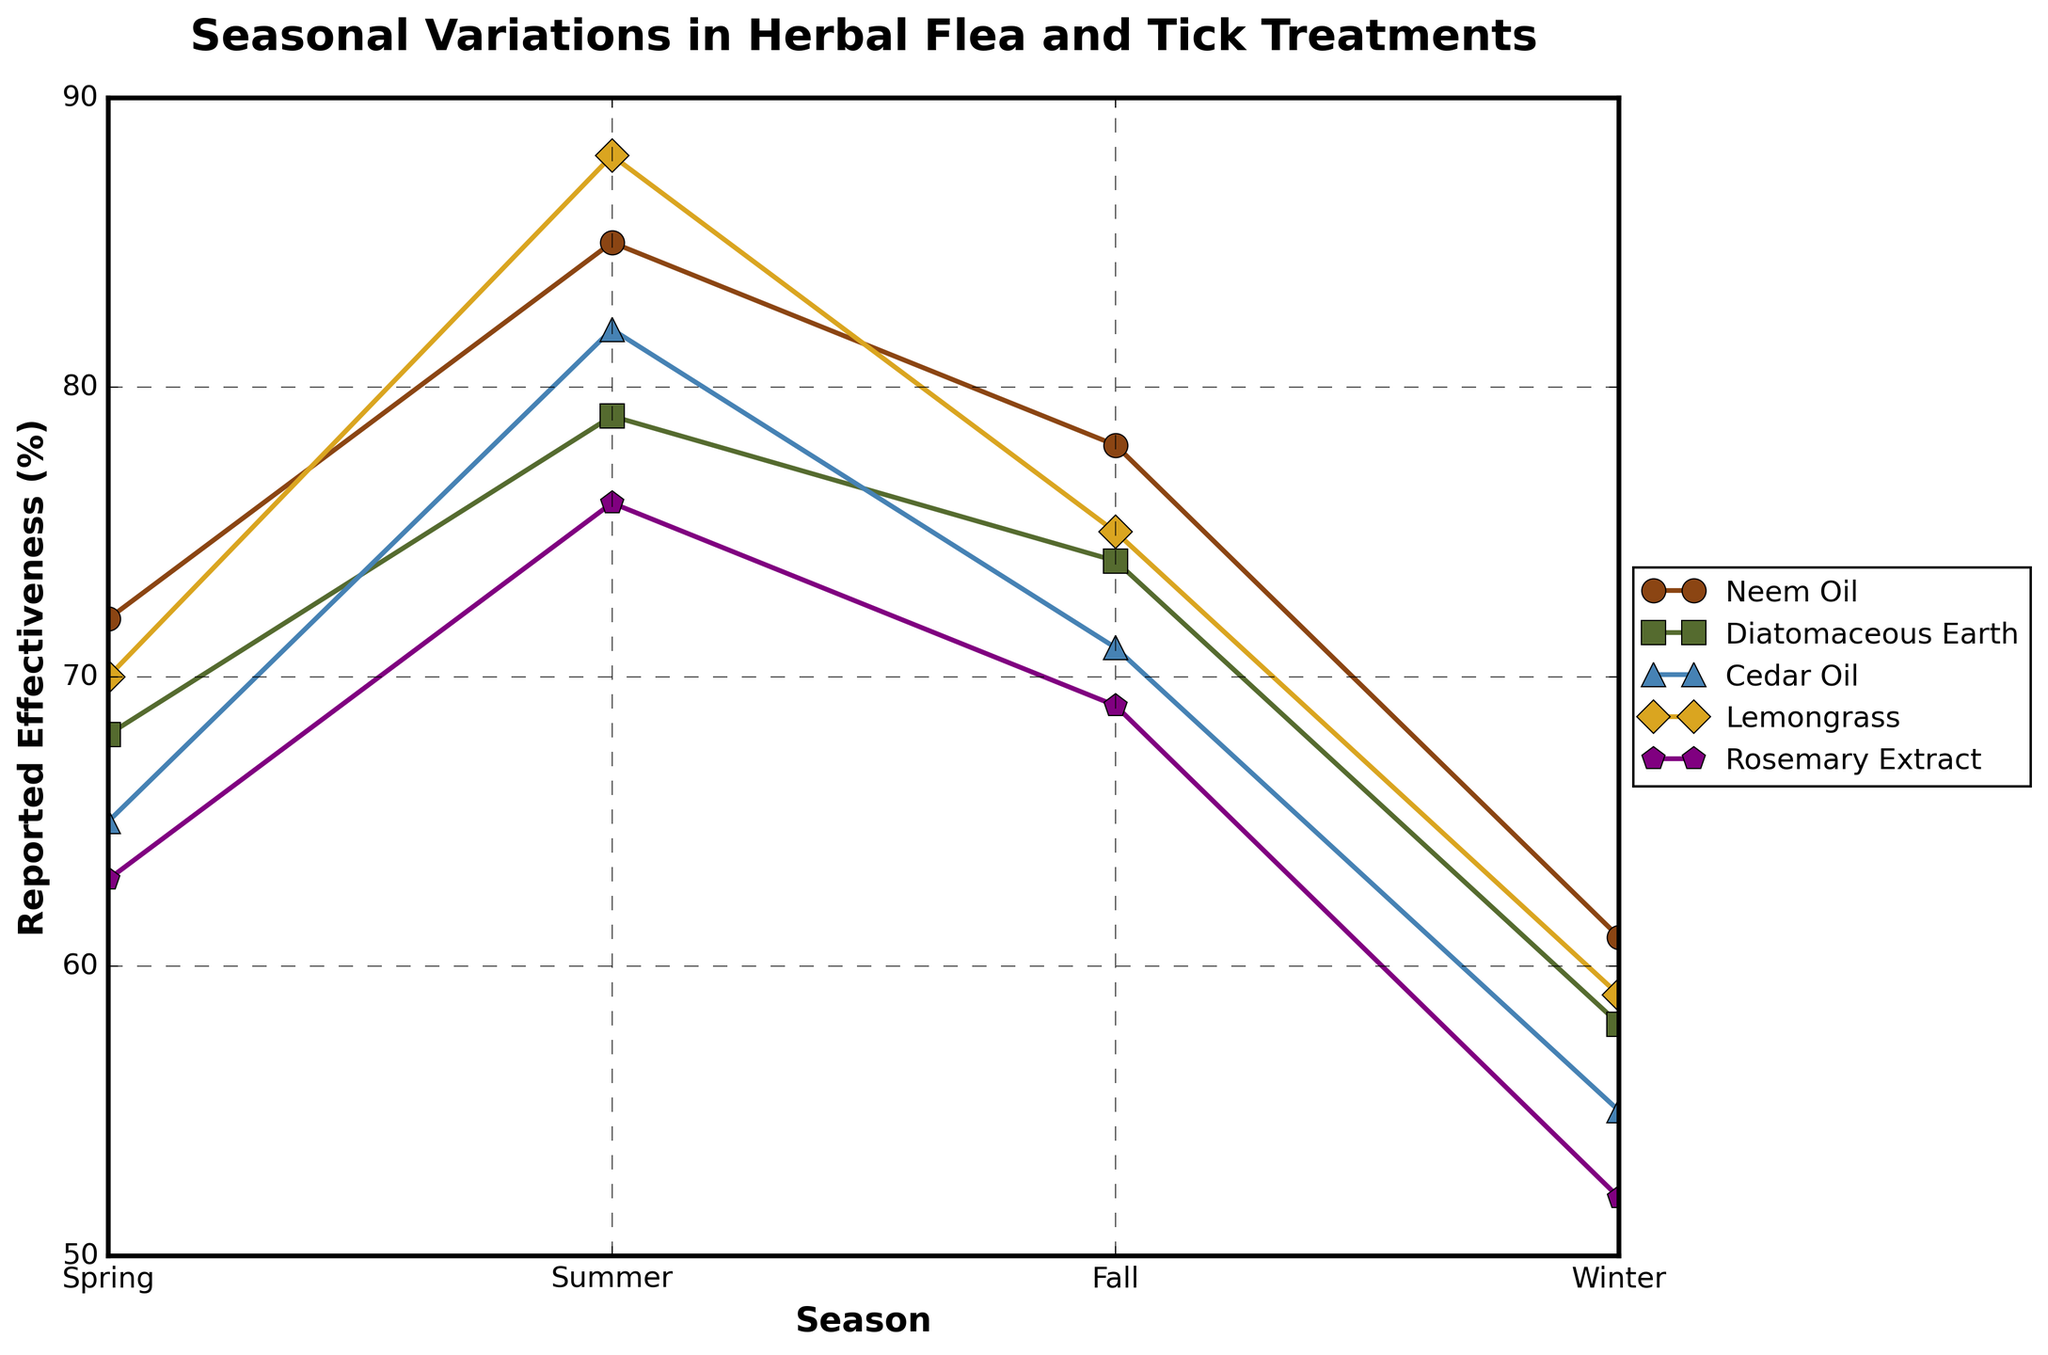What's the overall trend of the effectiveness of Neem Oil across seasons? Neem Oil's effectiveness shows a peak in Summer at 85%, declines in Fall to 78%, and further drops in Winter to 61%. It starts rising again in Spring to 72%. So, the trend is a peak in Summer and a dip in Winter.
Answer: Peak in Summer, Dip in Winter Which treatment maintains the most consistent effectiveness throughout the year? To determine consistency, we need to identify the treatment with the smallest range of effectiveness values over the seasons. Diatomaceous Earth ranges from 58% to 79% (a range of 21%), Cedar Oil ranges from 55% to 82% (a range of 27%), Neem Oil ranges from 61% to 85% (a range of 24%), Lemongrass ranges from 59% to 88% (a range of 29%), and Rosemary Extract ranges from 52% to 76% (a range of 24%). Diatomaceous Earth has the smallest range, indicating the most consistent effectiveness.
Answer: Diatomaceous Earth Which season shows the highest effectiveness for Lemongrass? By looking at the plot, we can see that Lemongrass's highest effectiveness is in Summer at 88%.
Answer: Summer Compare the effectiveness of Cedar Oil and Rosemary Extract in Fall. Which one is more effective? In Fall, Cedar Oil's effectiveness is 71%, and Rosemary Extract's is 69%. Therefore, Cedar Oil is more effective in Fall.
Answer: Cedar Oil What is the average effectiveness of Diatomaceous Earth across all seasons? To find the average effectiveness of Diatomaceous Earth, we sum its effectiveness values across all seasons: 68 + 79 + 74 + 58 = 279. Then we divide by the number of seasons: 279 / 4 = 69.75%.
Answer: 69.75% How does the effectiveness of Neem Oil in Spring compare to Winter? In Spring, Neem Oil's effectiveness is 72%, and in Winter, it is 61%. Neem Oil is more effective in Spring compared to Winter, with a difference of 11%.
Answer: 72% in Spring, 61% in Winter, difference of 11% Among all treatments, which one shows the highest increase in effectiveness from Spring to Summer? We calculate the increase in effectiveness for each treatment from Spring to Summer: Neem Oil rises from 72% to 85% (13% increase), Diatomaceous Earth from 68% to 79% (11% increase), Cedar Oil from 65% to 82% (17% increase), Lemongrass from 70% to 88% (18% increase), and Rosemary Extract from 63% to 76% (13% increase). Lemongrass shows the highest increase of 18%.
Answer: Lemongrass Identify the treatment with the lowest effectiveness in Winter. By looking at the plot's Winter data points, Rosemary Extract has the lowest effectiveness at 52%.
Answer: Rosemary Extract 